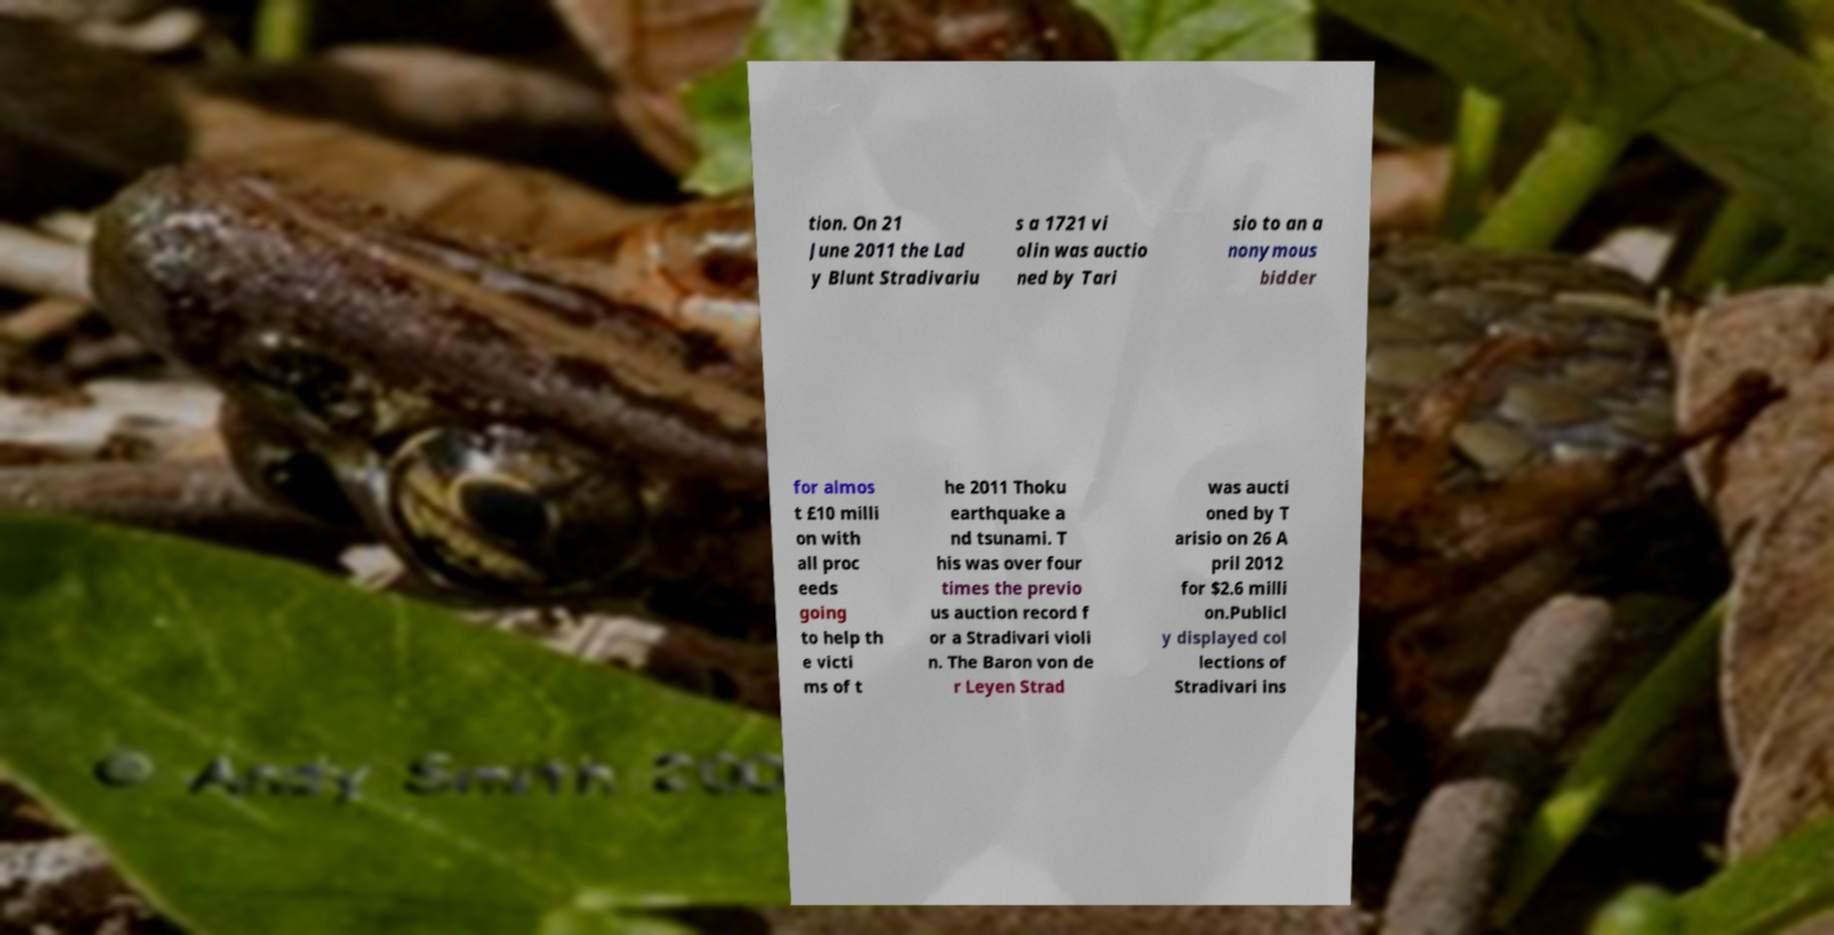Can you read and provide the text displayed in the image?This photo seems to have some interesting text. Can you extract and type it out for me? tion. On 21 June 2011 the Lad y Blunt Stradivariu s a 1721 vi olin was auctio ned by Tari sio to an a nonymous bidder for almos t £10 milli on with all proc eeds going to help th e victi ms of t he 2011 Thoku earthquake a nd tsunami. T his was over four times the previo us auction record f or a Stradivari violi n. The Baron von de r Leyen Strad was aucti oned by T arisio on 26 A pril 2012 for $2.6 milli on.Publicl y displayed col lections of Stradivari ins 